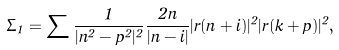Convert formula to latex. <formula><loc_0><loc_0><loc_500><loc_500>\Sigma _ { 1 } = \sum \frac { 1 } { | n ^ { 2 } - p ^ { 2 } | ^ { 2 } } \frac { 2 n } { | n - i | } | r ( n + i ) | ^ { 2 } | r ( k + p ) | ^ { 2 } ,</formula> 